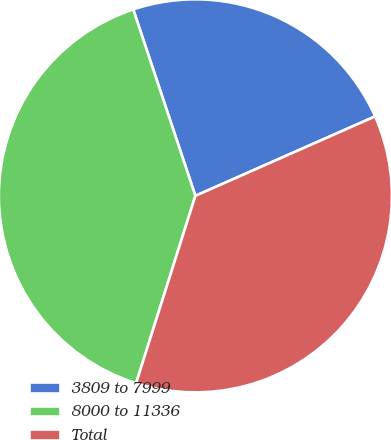Convert chart. <chart><loc_0><loc_0><loc_500><loc_500><pie_chart><fcel>3809 to 7999<fcel>8000 to 11336<fcel>Total<nl><fcel>23.5%<fcel>40.0%<fcel>36.5%<nl></chart> 